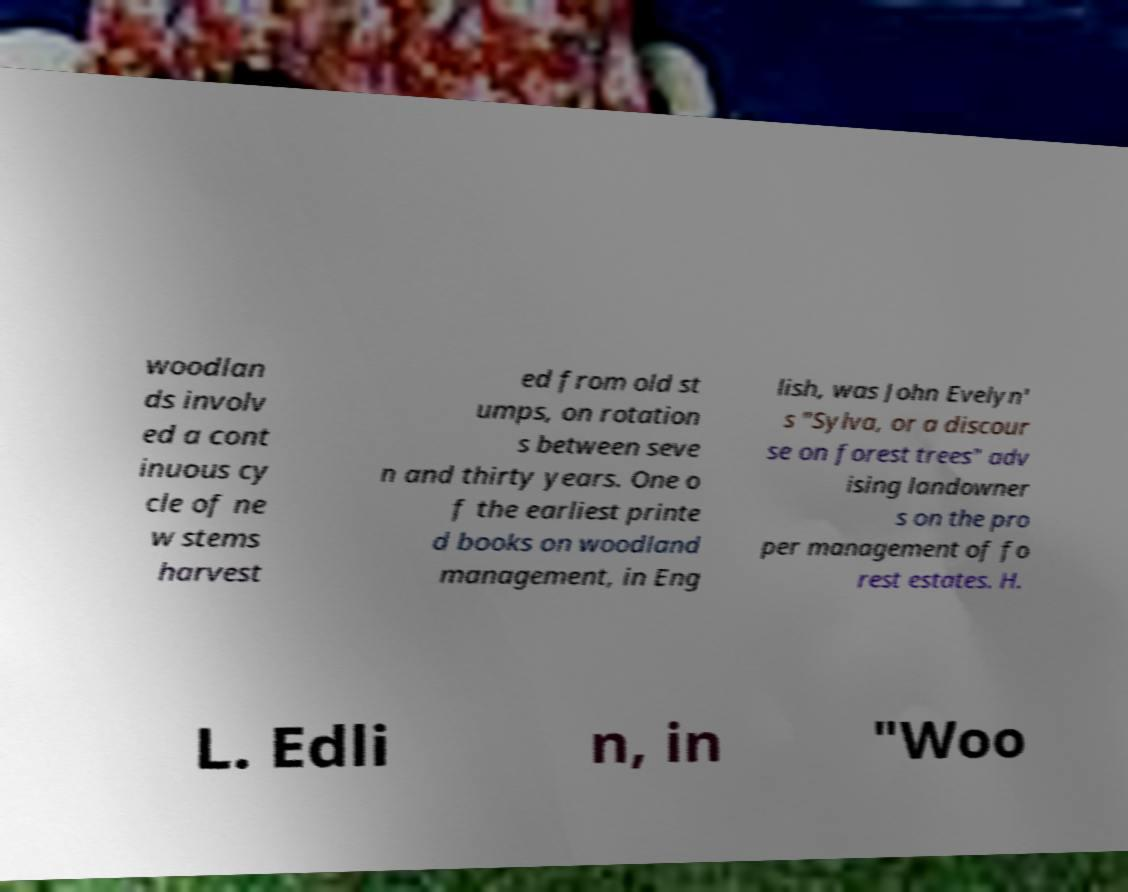I need the written content from this picture converted into text. Can you do that? woodlan ds involv ed a cont inuous cy cle of ne w stems harvest ed from old st umps, on rotation s between seve n and thirty years. One o f the earliest printe d books on woodland management, in Eng lish, was John Evelyn' s "Sylva, or a discour se on forest trees" adv ising landowner s on the pro per management of fo rest estates. H. L. Edli n, in "Woo 